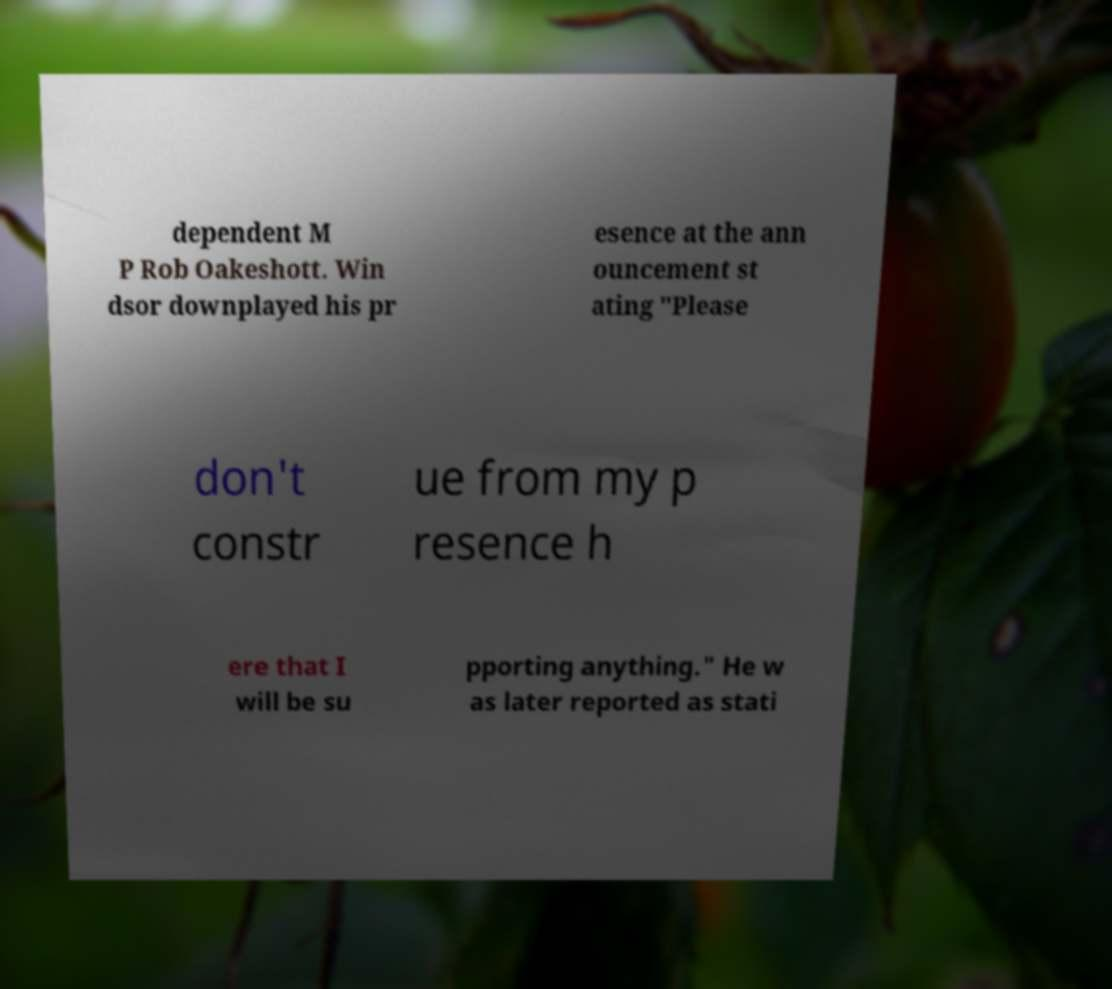Please read and relay the text visible in this image. What does it say? dependent M P Rob Oakeshott. Win dsor downplayed his pr esence at the ann ouncement st ating "Please don't constr ue from my p resence h ere that I will be su pporting anything." He w as later reported as stati 